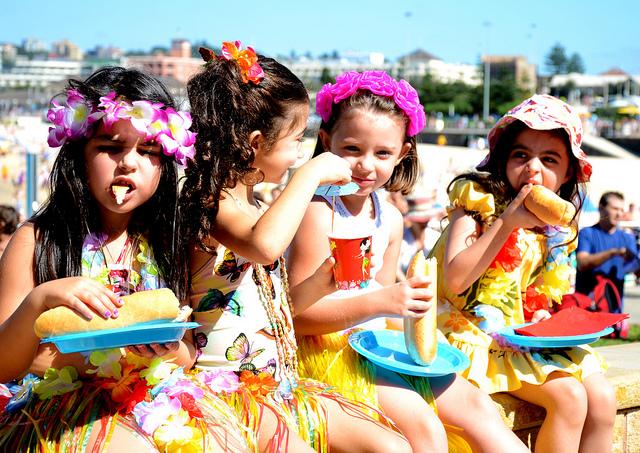How many children are here?
Give a very brief answer. 4. What snake are the children eating?
Give a very brief answer. None. What kind of costuming do the girls wear?
Quick response, please. Hawaiian. 